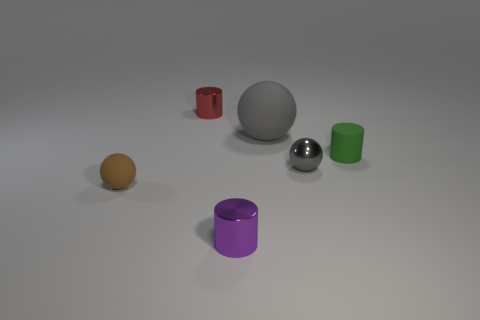Is there a small green rubber object that has the same shape as the tiny brown matte object?
Keep it short and to the point. No. What shape is the green thing that is the same size as the purple shiny cylinder?
Keep it short and to the point. Cylinder. How many objects are either tiny red matte balls or small spheres?
Ensure brevity in your answer.  2. Is there a green shiny object?
Your answer should be compact. No. Is the number of big objects less than the number of small purple matte cylinders?
Offer a very short reply. No. Is there a gray sphere of the same size as the purple metal cylinder?
Your response must be concise. Yes. Do the red metal thing and the matte object that is to the right of the small gray object have the same shape?
Your response must be concise. Yes. How many cylinders are gray things or red shiny things?
Your answer should be compact. 1. What is the color of the large sphere?
Your answer should be compact. Gray. Is the number of tiny brown shiny balls greater than the number of big matte spheres?
Provide a short and direct response. No. 